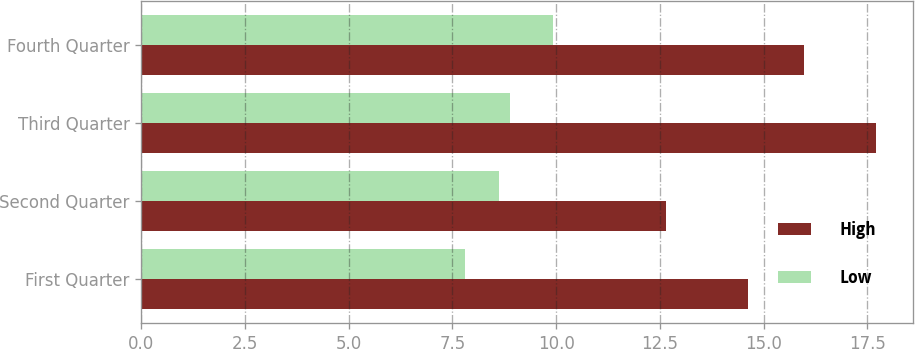Convert chart. <chart><loc_0><loc_0><loc_500><loc_500><stacked_bar_chart><ecel><fcel>First Quarter<fcel>Second Quarter<fcel>Third Quarter<fcel>Fourth Quarter<nl><fcel>High<fcel>14.63<fcel>12.64<fcel>17.7<fcel>15.97<nl><fcel>Low<fcel>7.8<fcel>8.63<fcel>8.88<fcel>9.92<nl></chart> 